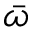Convert formula to latex. <formula><loc_0><loc_0><loc_500><loc_500>\bar { \omega }</formula> 